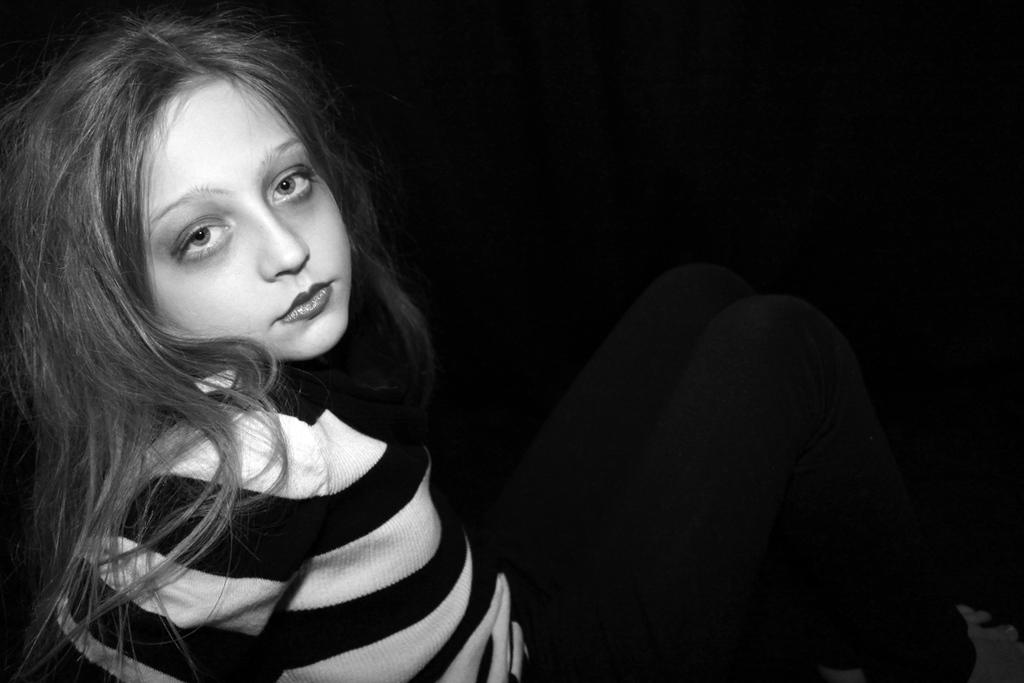Who is the main subject in the image? There is a girl in the image. What is the girl wearing? The girl is wearing a black and white striped t-shirt. What color is the background of the image? The background of the image is black. What type of cheese can be seen rolling down the slope in the image? There is no cheese or slope present in the image; it features a girl wearing a black and white striped t-shirt against a black background. 